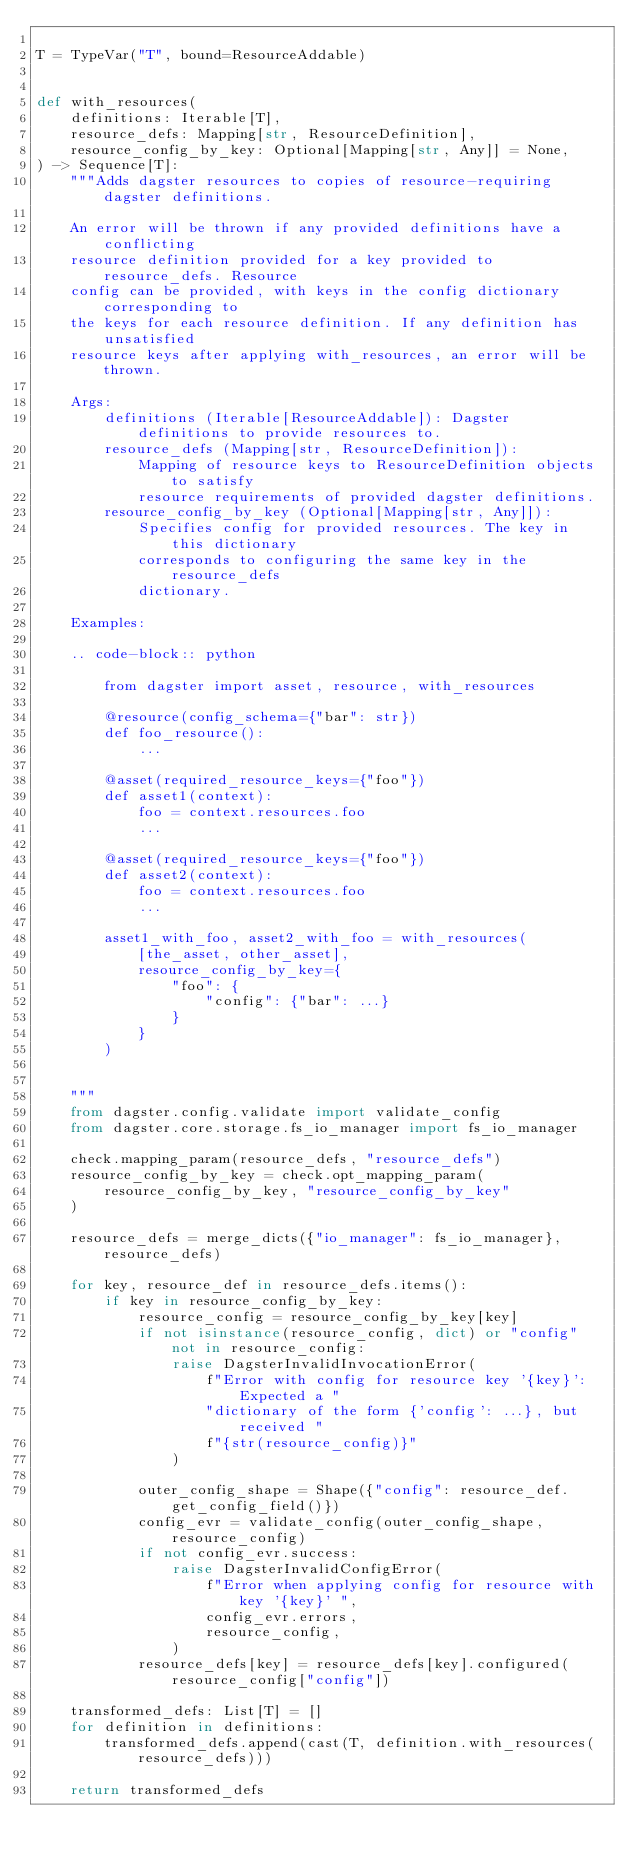<code> <loc_0><loc_0><loc_500><loc_500><_Python_>
T = TypeVar("T", bound=ResourceAddable)


def with_resources(
    definitions: Iterable[T],
    resource_defs: Mapping[str, ResourceDefinition],
    resource_config_by_key: Optional[Mapping[str, Any]] = None,
) -> Sequence[T]:
    """Adds dagster resources to copies of resource-requiring dagster definitions.

    An error will be thrown if any provided definitions have a conflicting
    resource definition provided for a key provided to resource_defs. Resource
    config can be provided, with keys in the config dictionary corresponding to
    the keys for each resource definition. If any definition has unsatisfied
    resource keys after applying with_resources, an error will be thrown.

    Args:
        definitions (Iterable[ResourceAddable]): Dagster definitions to provide resources to.
        resource_defs (Mapping[str, ResourceDefinition]):
            Mapping of resource keys to ResourceDefinition objects to satisfy
            resource requirements of provided dagster definitions.
        resource_config_by_key (Optional[Mapping[str, Any]]):
            Specifies config for provided resources. The key in this dictionary
            corresponds to configuring the same key in the resource_defs
            dictionary.

    Examples:

    .. code-block:: python

        from dagster import asset, resource, with_resources

        @resource(config_schema={"bar": str})
        def foo_resource():
            ...

        @asset(required_resource_keys={"foo"})
        def asset1(context):
            foo = context.resources.foo
            ...

        @asset(required_resource_keys={"foo"})
        def asset2(context):
            foo = context.resources.foo
            ...

        asset1_with_foo, asset2_with_foo = with_resources(
            [the_asset, other_asset],
            resource_config_by_key={
                "foo": {
                    "config": {"bar": ...}
                }
            }
        )


    """
    from dagster.config.validate import validate_config
    from dagster.core.storage.fs_io_manager import fs_io_manager

    check.mapping_param(resource_defs, "resource_defs")
    resource_config_by_key = check.opt_mapping_param(
        resource_config_by_key, "resource_config_by_key"
    )

    resource_defs = merge_dicts({"io_manager": fs_io_manager}, resource_defs)

    for key, resource_def in resource_defs.items():
        if key in resource_config_by_key:
            resource_config = resource_config_by_key[key]
            if not isinstance(resource_config, dict) or "config" not in resource_config:
                raise DagsterInvalidInvocationError(
                    f"Error with config for resource key '{key}': Expected a "
                    "dictionary of the form {'config': ...}, but received "
                    f"{str(resource_config)}"
                )

            outer_config_shape = Shape({"config": resource_def.get_config_field()})
            config_evr = validate_config(outer_config_shape, resource_config)
            if not config_evr.success:
                raise DagsterInvalidConfigError(
                    f"Error when applying config for resource with key '{key}' ",
                    config_evr.errors,
                    resource_config,
                )
            resource_defs[key] = resource_defs[key].configured(resource_config["config"])

    transformed_defs: List[T] = []
    for definition in definitions:
        transformed_defs.append(cast(T, definition.with_resources(resource_defs)))

    return transformed_defs
</code> 